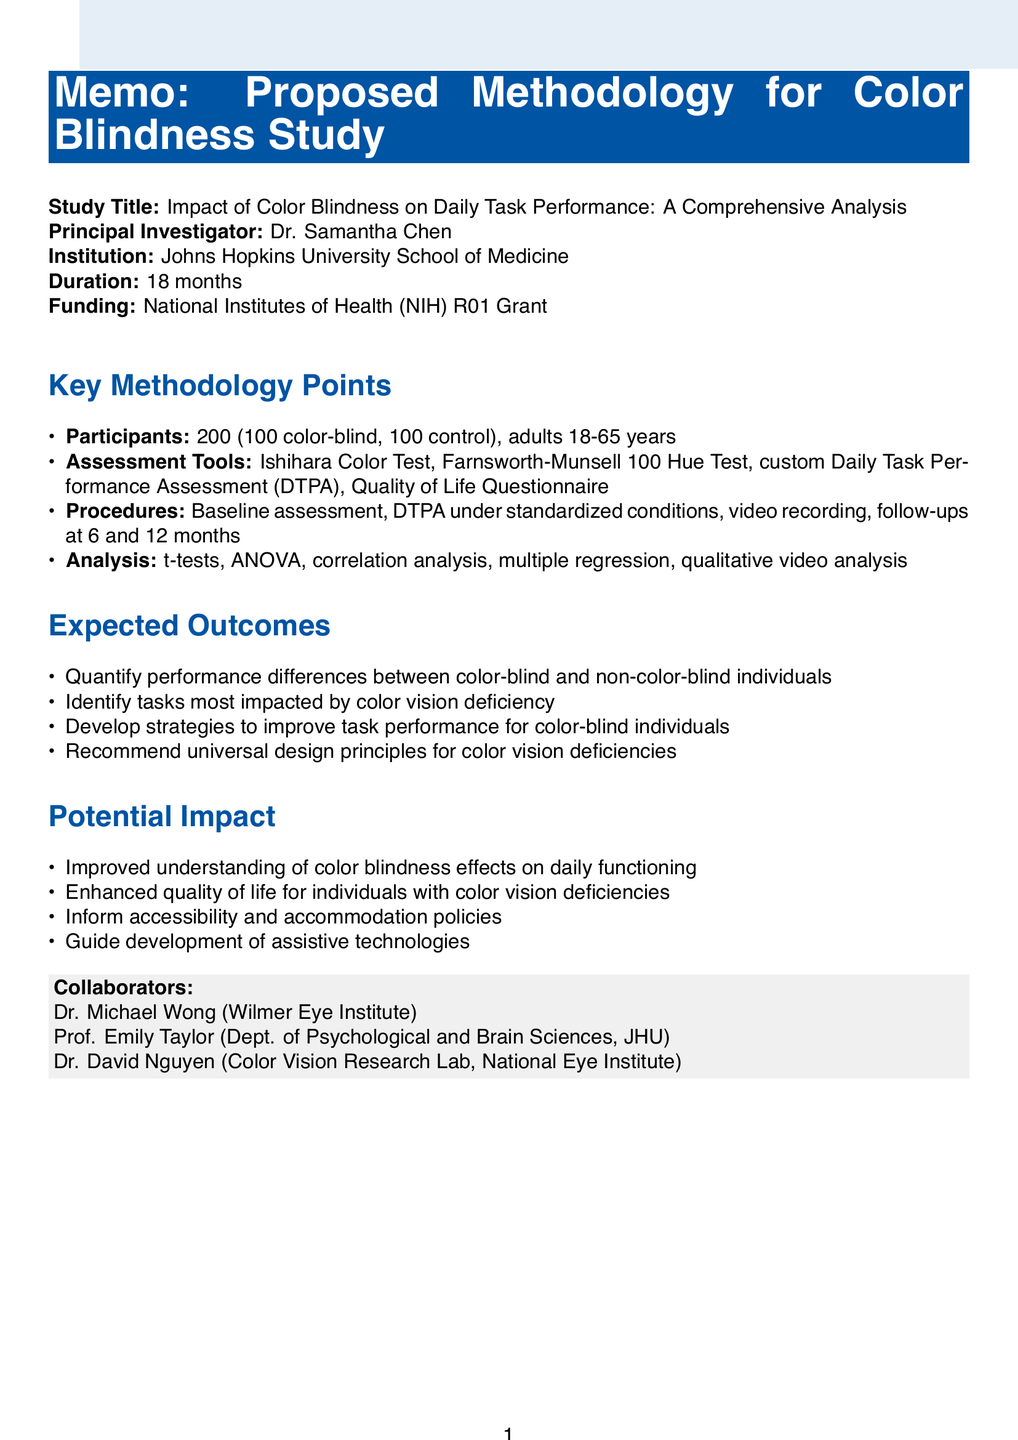What is the title of the study? The title of the study is mentioned prominently in the document.
Answer: Impact of Color Blindness on Daily Task Performance: A Comprehensive Analysis Who is the principal investigator? The document states the name of the principal investigator.
Answer: Dr. Samantha Chen What is the study duration? The document provides the total duration of the study in months.
Answer: 18 months How many participants will be recruited? The document specifies the target sample size for the study.
Answer: 200 participants What tools will be used for assessment? The document lists the assessment tools to be used in the study.
Answer: Ishihara Color Test, Farnsworth-Munsell 100 Hue Test, DTPA, QLCVD What analysis methods will be employed? The document mentions specific analysis methods that will be utilized in the study.
Answer: t-tests, ANOVA, correlation analysis, multiple regression, qualitative video analysis What ethical approval is required? The document indicates an institutional review board approval is necessary for the study.
Answer: IRB approval from Johns Hopkins Medicine Institutional Review Board What funding source is mentioned? The document specifies the funding source for the study.
Answer: National Institutes of Health (NIH) R01 Grant What is one expected outcome of the study? The document outlines potential outcomes of the study.
Answer: Quantification of daily task performance differences between color-blind and non-color-blind individuals 